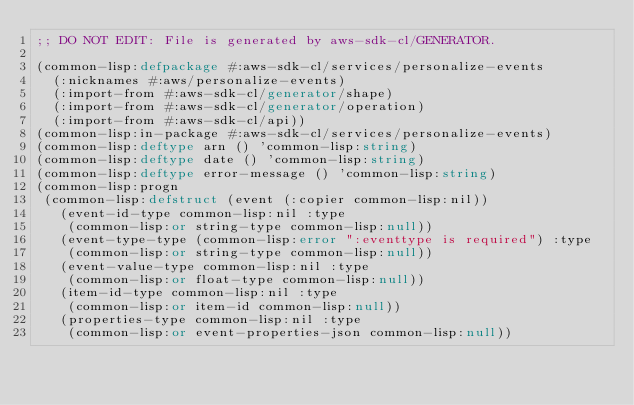Convert code to text. <code><loc_0><loc_0><loc_500><loc_500><_Lisp_>;; DO NOT EDIT: File is generated by aws-sdk-cl/GENERATOR.

(common-lisp:defpackage #:aws-sdk-cl/services/personalize-events
  (:nicknames #:aws/personalize-events)
  (:import-from #:aws-sdk-cl/generator/shape)
  (:import-from #:aws-sdk-cl/generator/operation)
  (:import-from #:aws-sdk-cl/api))
(common-lisp:in-package #:aws-sdk-cl/services/personalize-events)
(common-lisp:deftype arn () 'common-lisp:string)
(common-lisp:deftype date () 'common-lisp:string)
(common-lisp:deftype error-message () 'common-lisp:string)
(common-lisp:progn
 (common-lisp:defstruct (event (:copier common-lisp:nil))
   (event-id-type common-lisp:nil :type
    (common-lisp:or string-type common-lisp:null))
   (event-type-type (common-lisp:error ":eventtype is required") :type
    (common-lisp:or string-type common-lisp:null))
   (event-value-type common-lisp:nil :type
    (common-lisp:or float-type common-lisp:null))
   (item-id-type common-lisp:nil :type
    (common-lisp:or item-id common-lisp:null))
   (properties-type common-lisp:nil :type
    (common-lisp:or event-properties-json common-lisp:null))</code> 